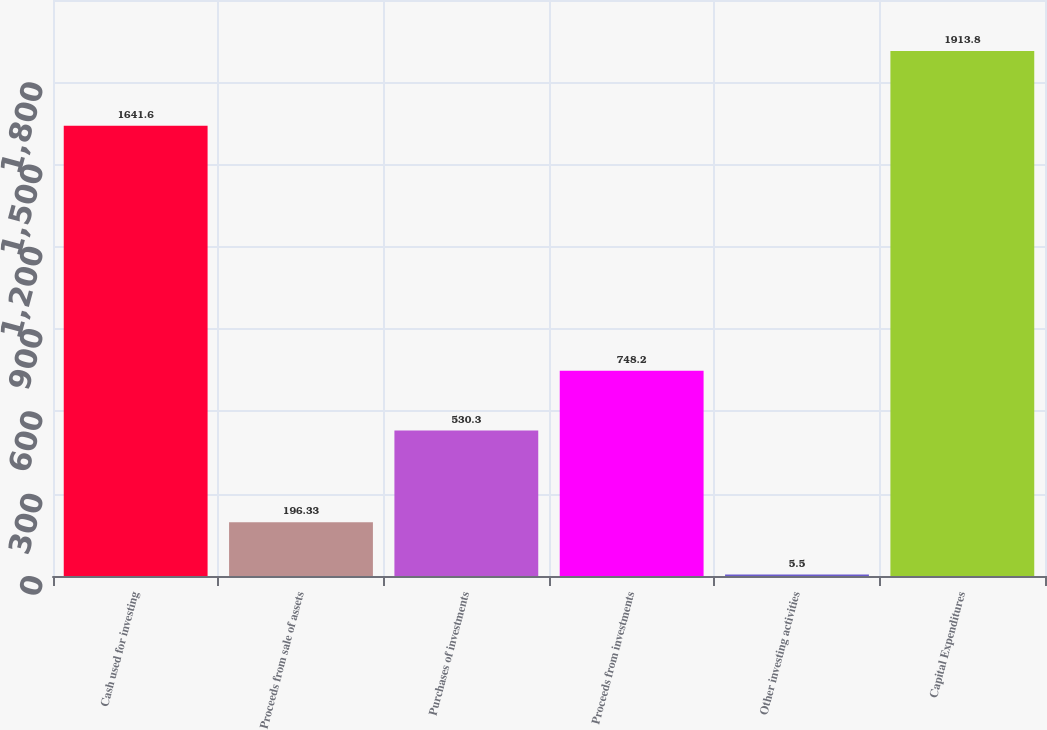<chart> <loc_0><loc_0><loc_500><loc_500><bar_chart><fcel>Cash used for investing<fcel>Proceeds from sale of assets<fcel>Purchases of investments<fcel>Proceeds from investments<fcel>Other investing activities<fcel>Capital Expenditures<nl><fcel>1641.6<fcel>196.33<fcel>530.3<fcel>748.2<fcel>5.5<fcel>1913.8<nl></chart> 